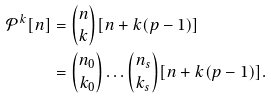<formula> <loc_0><loc_0><loc_500><loc_500>\mathcal { P } ^ { k } [ n ] & = \binom { n } { k } [ n + k ( p - 1 ) ] \\ & = \binom { n _ { 0 } } { k _ { 0 } } \dots \binom { n _ { s } } { k _ { s } } [ n + k ( p - 1 ) ] .</formula> 